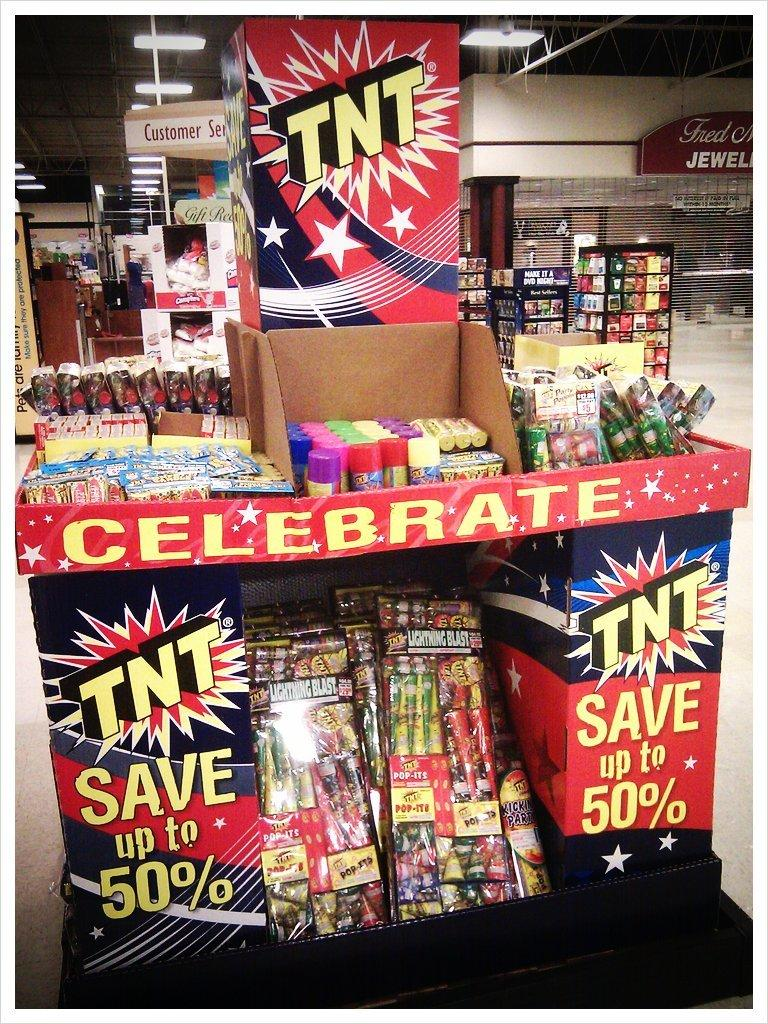<image>
Give a short and clear explanation of the subsequent image. A display of fireworks labeled TNT that are on sale for 50% off. 